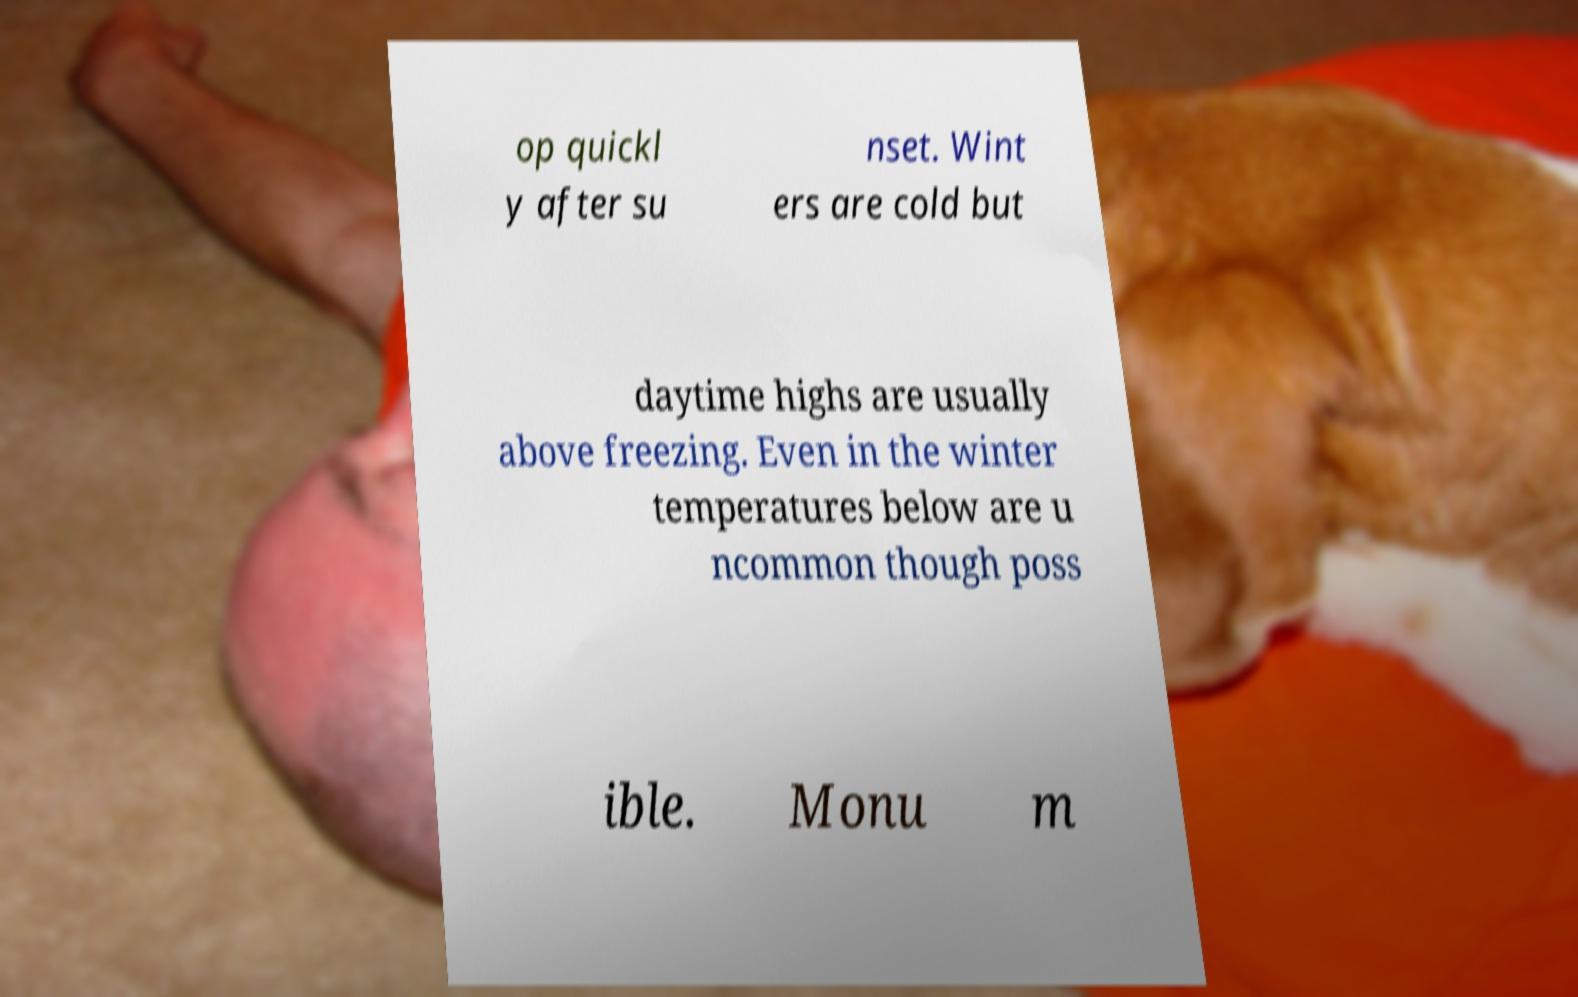Could you assist in decoding the text presented in this image and type it out clearly? op quickl y after su nset. Wint ers are cold but daytime highs are usually above freezing. Even in the winter temperatures below are u ncommon though poss ible. Monu m 